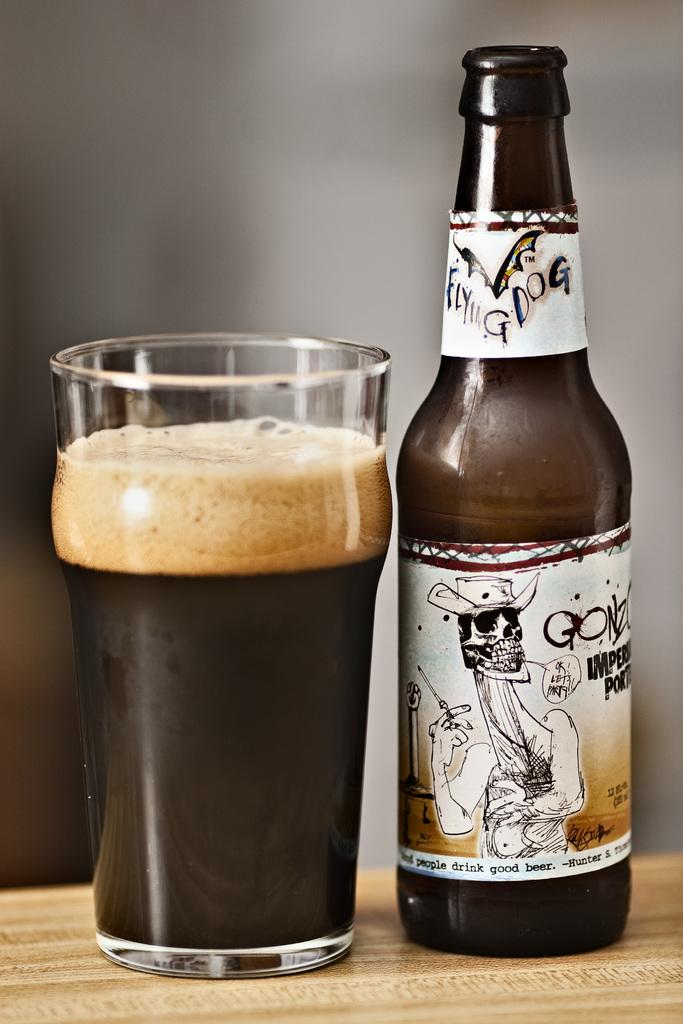<image>
Give a short and clear explanation of the subsequent image. Beer label showing a skeleton saying "OK! Let's Party!". 